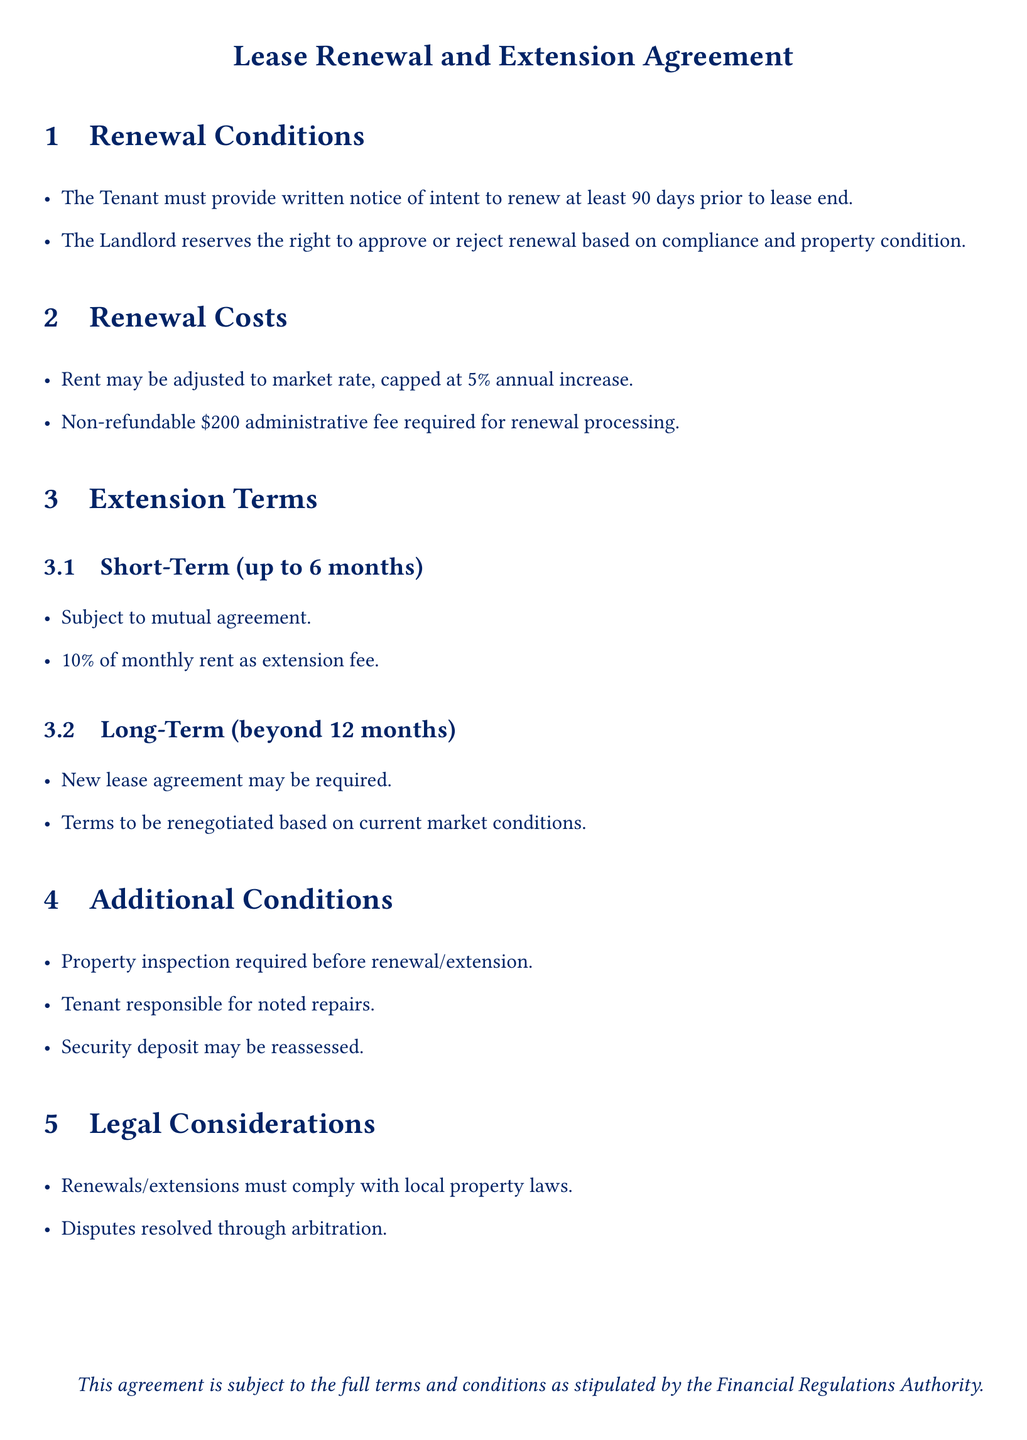What is the notice period for lease renewal? The Tenant must provide written notice of intent to renew at least 90 days prior to lease end.
Answer: 90 days What is the maximum allowed annual rent increase? Rent may be adjusted to market rate, capped at 5% annual increase.
Answer: 5% What is the non-refundable fee for renewal processing? A non-refundable $200 administrative fee is required for renewal processing.
Answer: $200 What percentage of monthly rent is the extension fee for a short-term extension? For a short-term extension, 10% of monthly rent is charged as an extension fee.
Answer: 10% What is required before renewal or extension? A property inspection is required before renewal/extension.
Answer: Property inspection What may happen to the security deposit during renewal? The security deposit may be reassessed.
Answer: Reassessed What must the tenant do if repairs are noted during the property inspection? Tenant is responsible for noted repairs.
Answer: Responsible for repairs What must all renewals/extensions comply with? Renewals/extensions must comply with local property laws.
Answer: Local property laws What dispute resolution method is mentioned? Disputes are resolved through arbitration.
Answer: Arbitration 